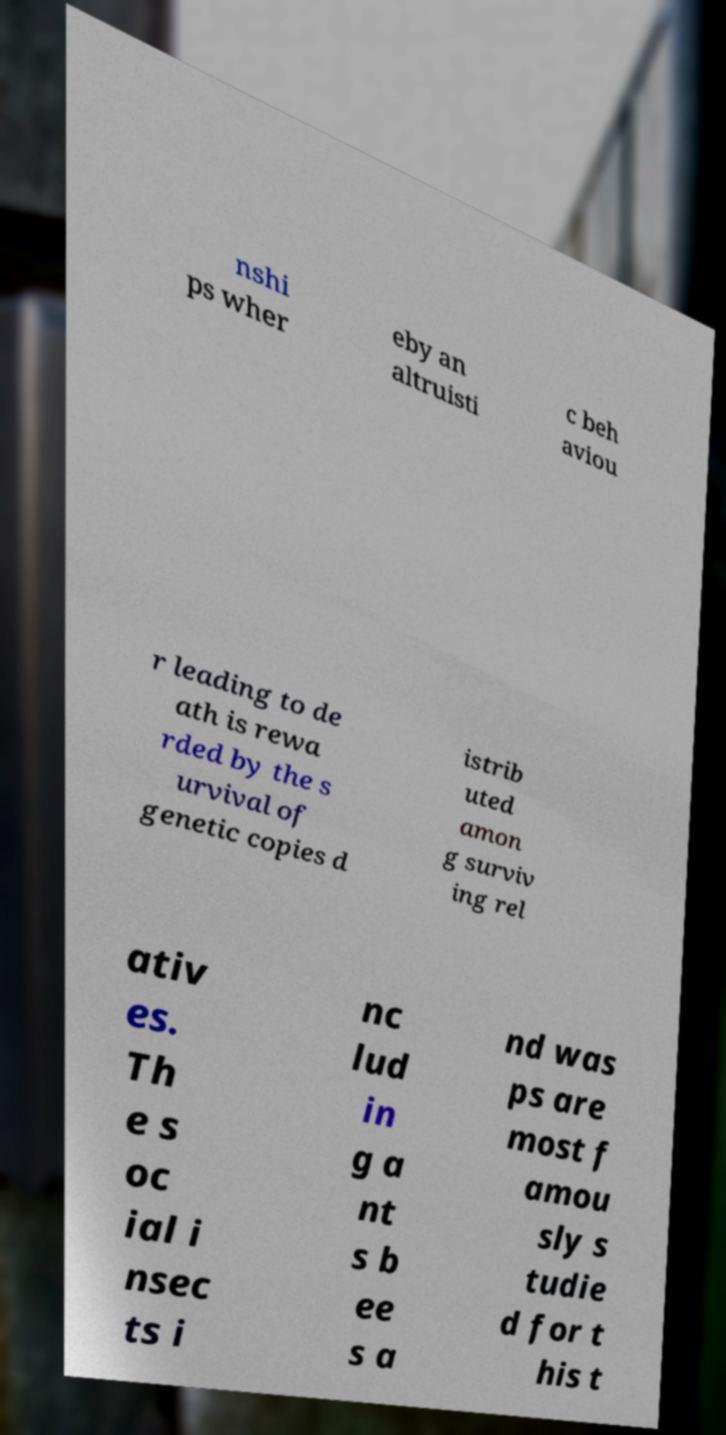I need the written content from this picture converted into text. Can you do that? nshi ps wher eby an altruisti c beh aviou r leading to de ath is rewa rded by the s urvival of genetic copies d istrib uted amon g surviv ing rel ativ es. Th e s oc ial i nsec ts i nc lud in g a nt s b ee s a nd was ps are most f amou sly s tudie d for t his t 